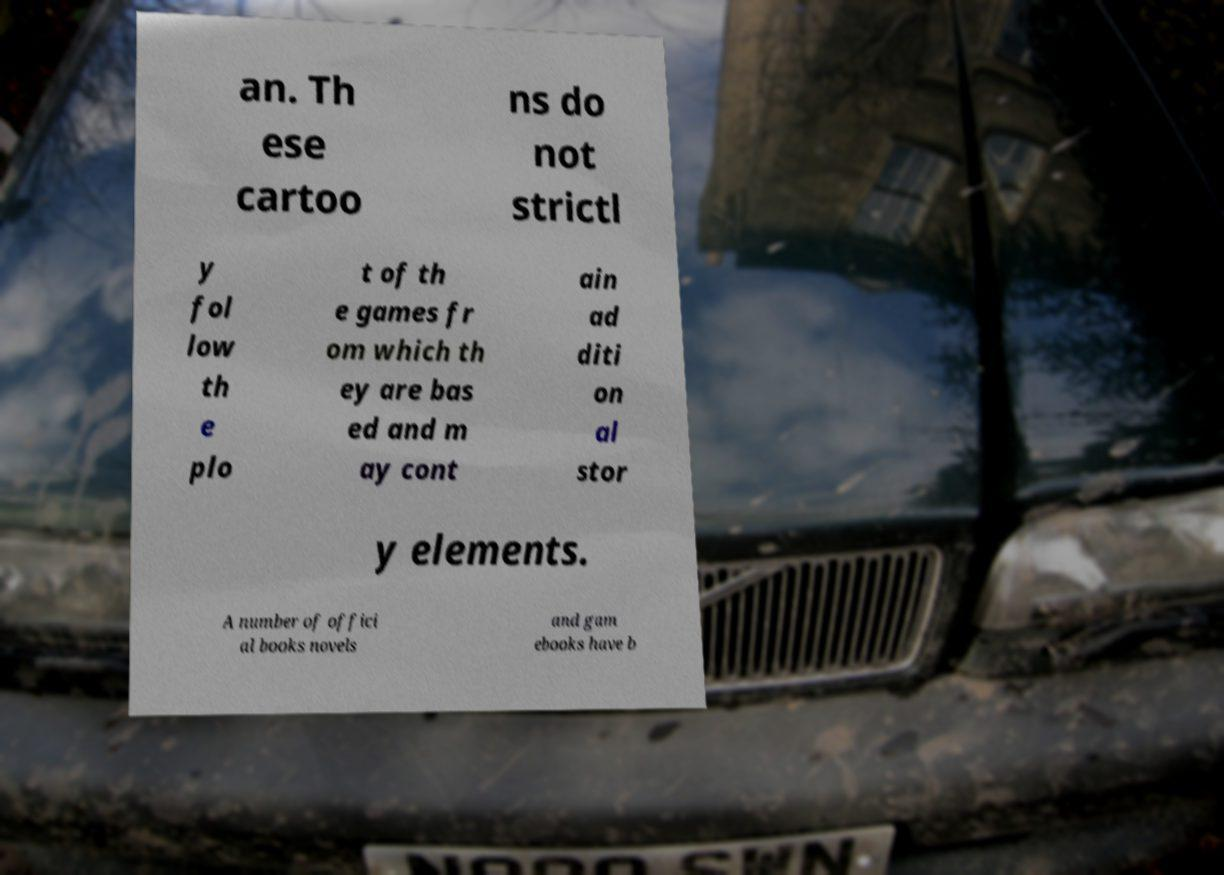What messages or text are displayed in this image? I need them in a readable, typed format. an. Th ese cartoo ns do not strictl y fol low th e plo t of th e games fr om which th ey are bas ed and m ay cont ain ad diti on al stor y elements. A number of offici al books novels and gam ebooks have b 